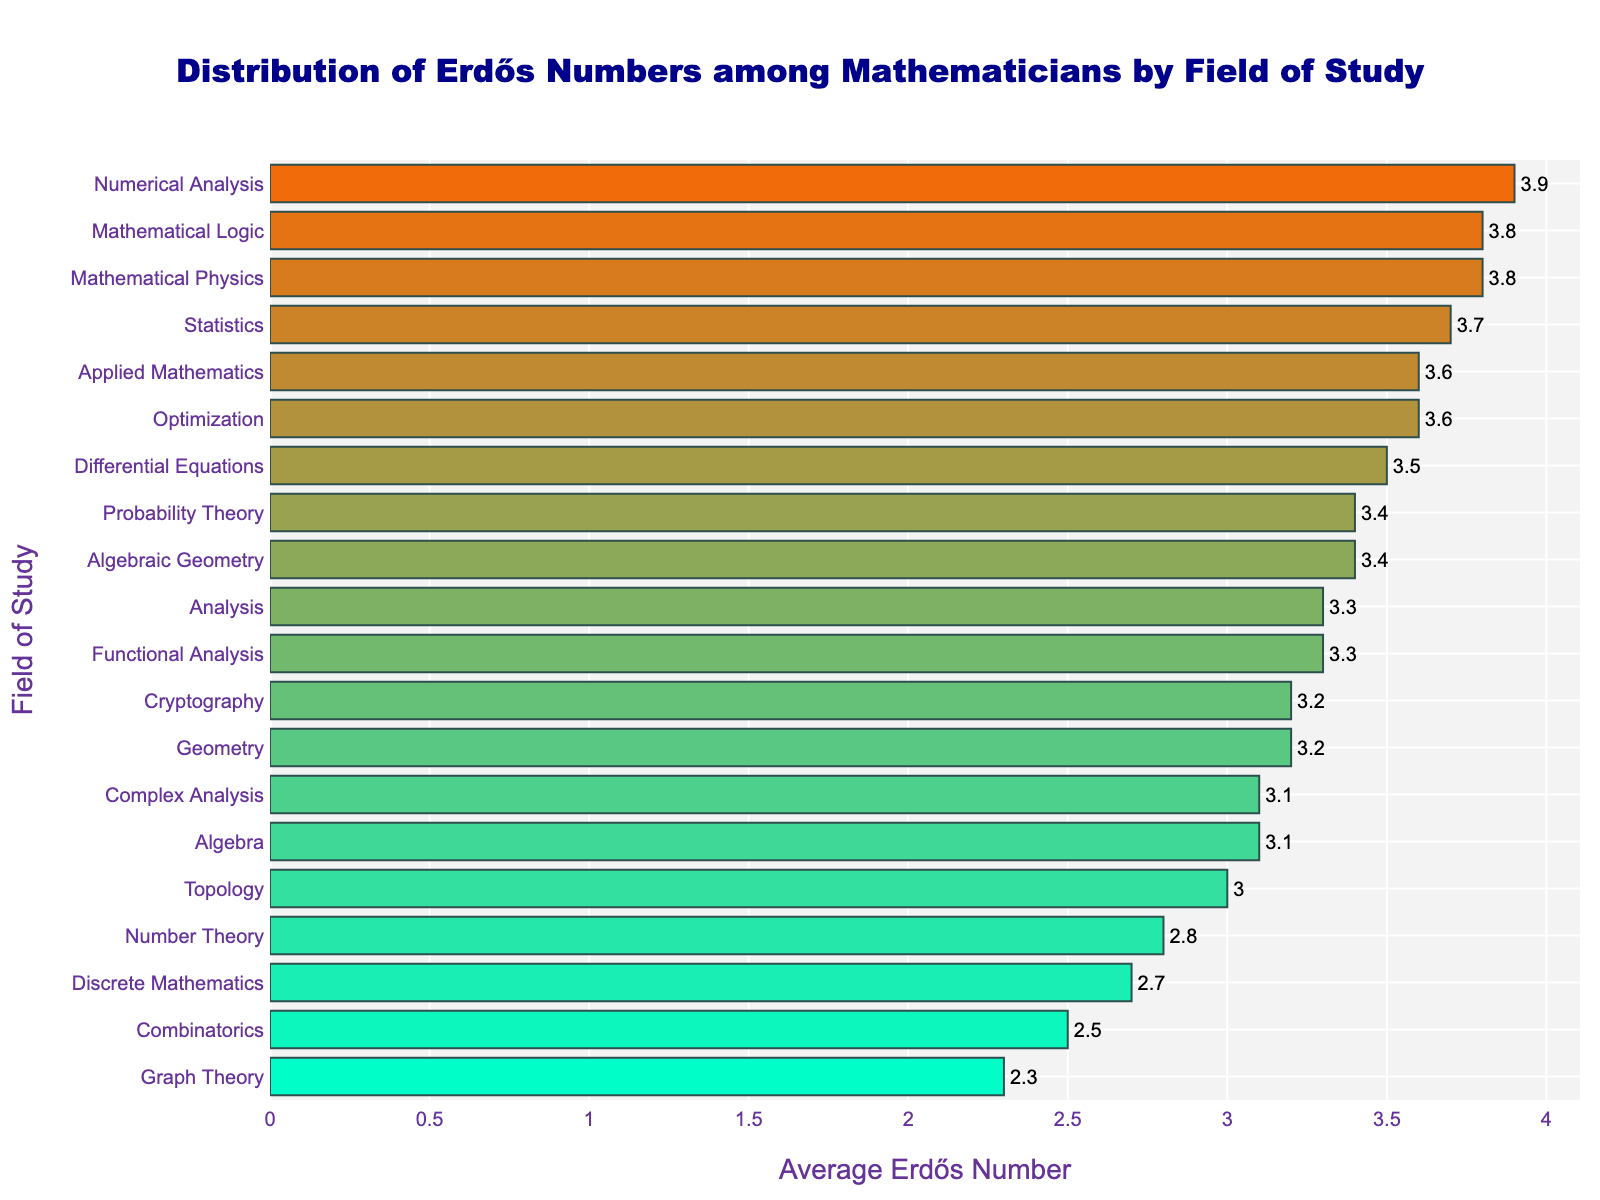Which field has the lowest average Erdős number? The bar with the lowest value indicates the field with the lowest average Erdős number, which is Graph Theory with a value of 2.3.
Answer: Graph Theory Which field has the highest average Erdős number, and what is that number? The bar with the highest value indicates the field with the highest average Erdős number, which is Numerical Analysis with a value of 3.9.
Answer: Numerical Analysis, 3.9 How many fields have an average Erdős number between 3.0 and 3.5? Count the bars whose values fall within the range 3.0 to 3.5. There are seven fields: Topology (3.0), Geometry (3.2), Cryptography (3.2), Analysis (3.3), Functional Analysis (3.3), Algebraic Geometry (3.4), and Probability Theory (3.4).
Answer: 7 What is the average Erdős number for Algebraic Geometry, and how does it compare to that of Probability Theory? The average Erdős numbers are 3.4 for both Algebraic Geometry and Probability Theory. Thus, they are equal.
Answer: 3.4, equal Which field has a closer average Erdős number to Combinatorics: Topology or Analysis? Combinatorics has an average Erdős number of 2.5. The average for Topology is 3.0 and for Analysis is 3.3. The difference from Combinatorics to Topology is 0.5, while the difference to Analysis is 0.8. Therefore, Topology is closer.
Answer: Topology What is the difference between the highest and lowest average Erdős numbers? The highest average Erdős number is 3.9, and the lowest is 2.3. The difference is 3.9 - 2.3 = 1.6.
Answer: 1.6 Which field is shown with the second-lowest average Erdős number? The second bar from the bottom that indicates the second-lowest value is Discrete Mathematics with an average Erdős number of 2.7.
Answer: Discrete Mathematics How many fields have an average Erdős number greater than or equal to 3.5? Count the bars that are equal to or greater than 3.5. There are five: Differential Equations (3.5), Optimization (3.6), Applied Mathematics (3.6), Statistics (3.7), Mathematical Logic (3.8), and Mathematical Physics (3.8).
Answer: 6 